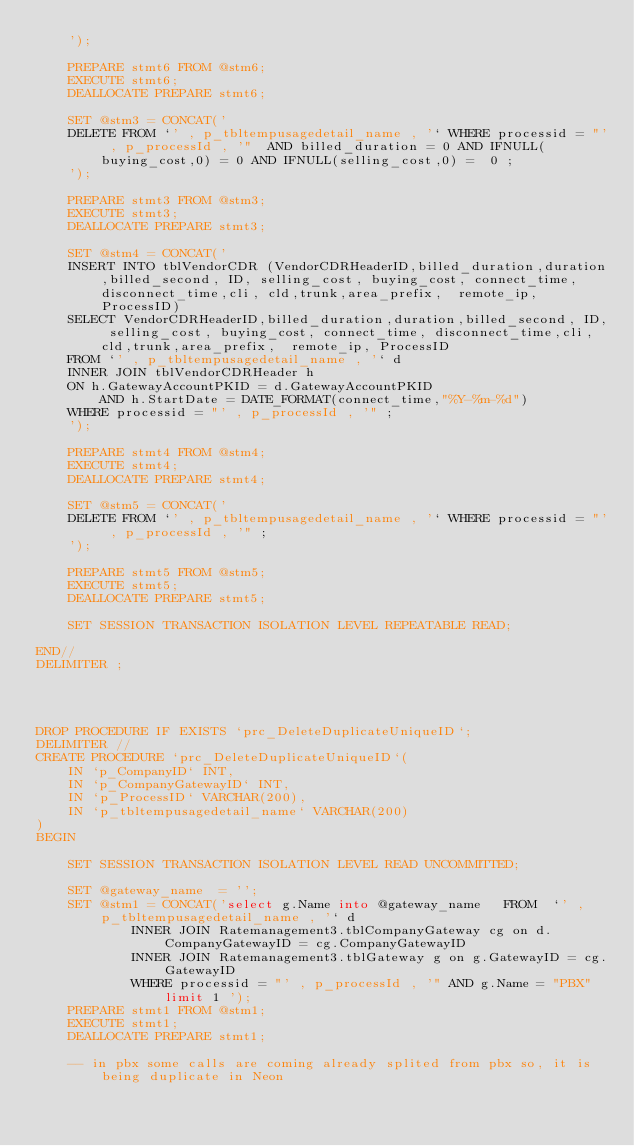<code> <loc_0><loc_0><loc_500><loc_500><_SQL_>	');

	PREPARE stmt6 FROM @stm6;
	EXECUTE stmt6;
	DEALLOCATE PREPARE stmt6;

	SET @stm3 = CONCAT('
	DELETE FROM `' , p_tbltempusagedetail_name , '` WHERE processid = "' , p_processId , '"  AND billed_duration = 0 AND IFNULL(buying_cost,0) = 0 AND IFNULL(selling_cost,0) =  0 ;
	');

	PREPARE stmt3 FROM @stm3;
	EXECUTE stmt3;
	DEALLOCATE PREPARE stmt3;

	SET @stm4 = CONCAT('
	INSERT INTO tblVendorCDR (VendorCDRHeaderID,billed_duration,duration,billed_second, ID, selling_cost, buying_cost, connect_time, disconnect_time,cli, cld,trunk,area_prefix,  remote_ip, ProcessID)
	SELECT VendorCDRHeaderID,billed_duration,duration,billed_second, ID, selling_cost, buying_cost, connect_time, disconnect_time,cli, cld,trunk,area_prefix,  remote_ip, ProcessID
	FROM `' , p_tbltempusagedetail_name , '` d
	INNER JOIN tblVendorCDRHeader h
	ON h.GatewayAccountPKID = d.GatewayAccountPKID
		AND h.StartDate = DATE_FORMAT(connect_time,"%Y-%m-%d")
	WHERE processid = "' , p_processId , '" ;
	');

	PREPARE stmt4 FROM @stm4;
	EXECUTE stmt4;
	DEALLOCATE PREPARE stmt4;

	SET @stm5 = CONCAT('
	DELETE FROM `' , p_tbltempusagedetail_name , '` WHERE processid = "' , p_processId , '" ;
	');

	PREPARE stmt5 FROM @stm5;
	EXECUTE stmt5;
	DEALLOCATE PREPARE stmt5;

	SET SESSION TRANSACTION ISOLATION LEVEL REPEATABLE READ;

END//
DELIMITER ;




DROP PROCEDURE IF EXISTS `prc_DeleteDuplicateUniqueID`;
DELIMITER //
CREATE PROCEDURE `prc_DeleteDuplicateUniqueID`(
	IN `p_CompanyID` INT,
	IN `p_CompanyGatewayID` INT,
	IN `p_ProcessID` VARCHAR(200),
	IN `p_tbltempusagedetail_name` VARCHAR(200)
)
BEGIN

 	SET SESSION TRANSACTION ISOLATION LEVEL READ UNCOMMITTED;

	SET @gateway_name  = '';
	SET @stm1 = CONCAT('select g.Name into @gateway_name   FROM  `' , p_tbltempusagedetail_name , '` d
			INNER JOIN Ratemanagement3.tblCompanyGateway cg on d.CompanyGatewayID = cg.CompanyGatewayID
			INNER JOIN Ratemanagement3.tblGateway g on g.GatewayID = cg.GatewayID
			WHERE processid = "' , p_processId , '" AND g.Name = "PBX" limit 1 ');
	PREPARE stmt1 FROM @stm1;
	EXECUTE stmt1;
	DEALLOCATE PREPARE stmt1;

 	-- in pbx some calls are coming already splited from pbx so, it is being duplicate in Neon</code> 